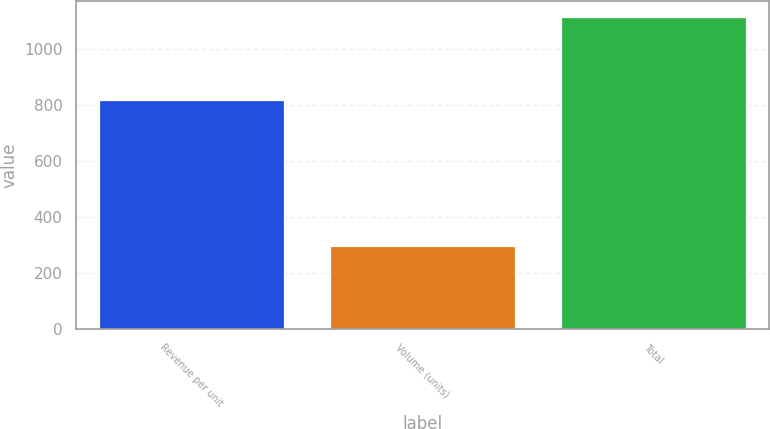Convert chart to OTSL. <chart><loc_0><loc_0><loc_500><loc_500><bar_chart><fcel>Revenue per unit<fcel>Volume (units)<fcel>Total<nl><fcel>816<fcel>297<fcel>1113<nl></chart> 